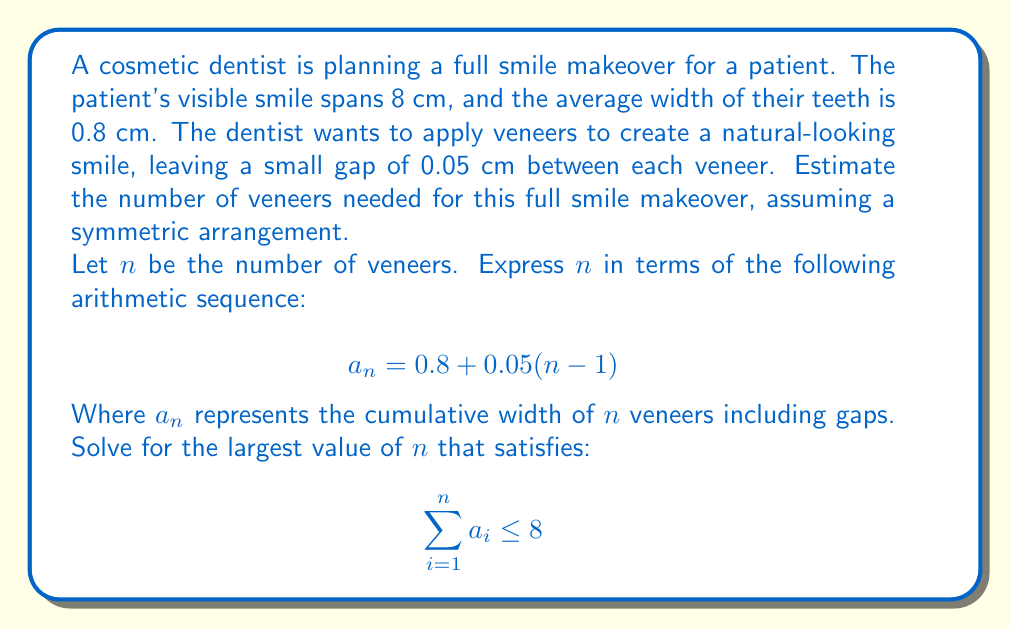Teach me how to tackle this problem. To solve this problem, we need to follow these steps:

1) First, let's write out the arithmetic sequence for the cumulative width of veneers:
   $$a_1 = 0.8$$
   $$a_2 = 0.8 + 0.05 = 0.85$$
   $$a_3 = 0.8 + 0.05(2) = 0.9$$
   ...and so on.

2) The sum of an arithmetic sequence is given by:
   $$S_n = \frac{n}{2}(a_1 + a_n)$$
   Where $a_1$ is the first term and $a_n$ is the last term.

3) We can express $a_n$ in terms of $n$:
   $$a_n = 0.8 + 0.05(n-1) = 0.75 + 0.05n$$

4) Now, let's substitute these into our sum formula:
   $$S_n = \frac{n}{2}(0.8 + (0.75 + 0.05n))$$
   $$S_n = \frac{n}{2}(1.55 + 0.05n)$$
   $$S_n = 0.775n + 0.025n^2$$

5) We want to find the largest $n$ where $S_n \leq 8$:
   $$0.775n + 0.025n^2 \leq 8$$

6) This is a quadratic inequality. We can solve it by finding the roots of the equation:
   $$0.025n^2 + 0.775n - 8 = 0$$

7) Using the quadratic formula:
   $$n = \frac{-0.775 \pm \sqrt{0.775^2 + 4(0.025)(8)}}{2(0.025)}$$
   $$n \approx 9.03 \text{ or } -40.03$$

8) Since we're looking for a positive number of veneers, and we need to round down to the nearest whole number (as we can't use partial veneers), our answer is 9.
Answer: The cosmetic dentist would need 9 veneers for the full smile makeover. 